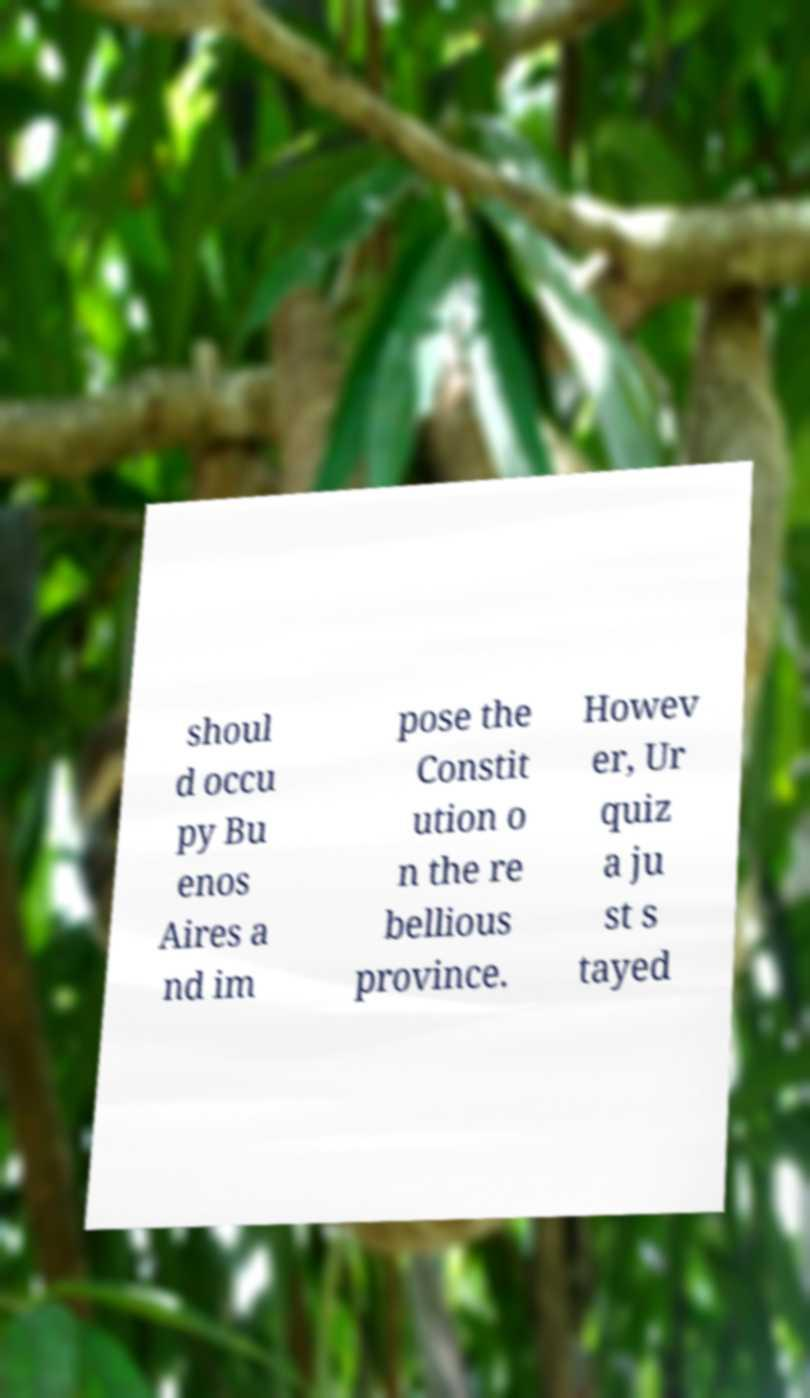Please read and relay the text visible in this image. What does it say? shoul d occu py Bu enos Aires a nd im pose the Constit ution o n the re bellious province. Howev er, Ur quiz a ju st s tayed 